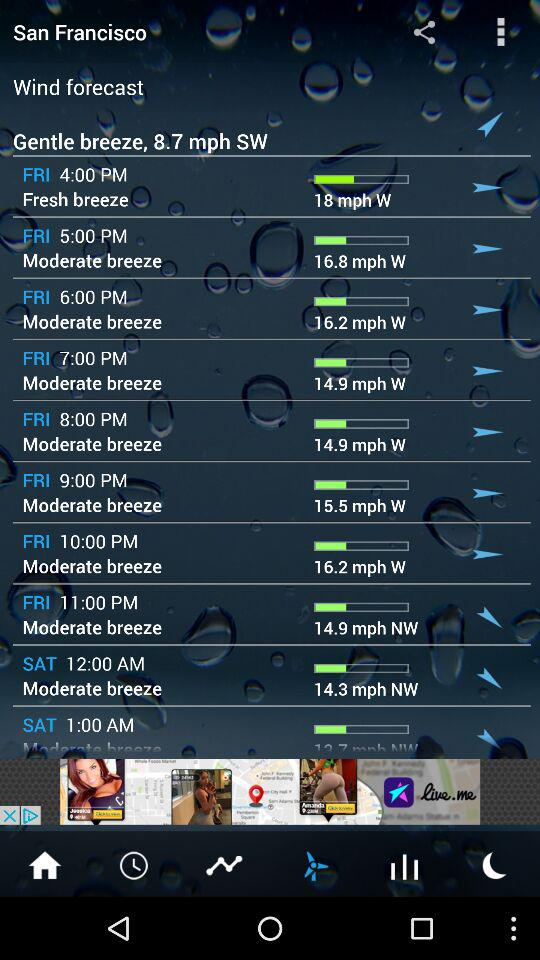What is the wind speed on Friday at 8 PM? The wind speed on Friday at 8 PM is 14.9 mph. 